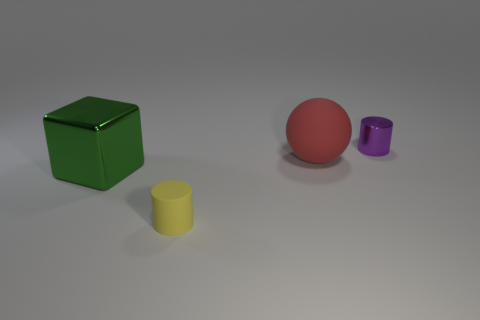Add 1 brown matte cylinders. How many objects exist? 5 Subtract all purple cylinders. How many cylinders are left? 1 Subtract 1 cylinders. How many cylinders are left? 1 Subtract all yellow spheres. Subtract all purple cylinders. How many spheres are left? 1 Subtract all gray cubes. How many brown balls are left? 0 Subtract all small blue rubber spheres. Subtract all yellow rubber cylinders. How many objects are left? 3 Add 2 green cubes. How many green cubes are left? 3 Add 1 large green metal cubes. How many large green metal cubes exist? 2 Subtract 1 red balls. How many objects are left? 3 Subtract all spheres. How many objects are left? 3 